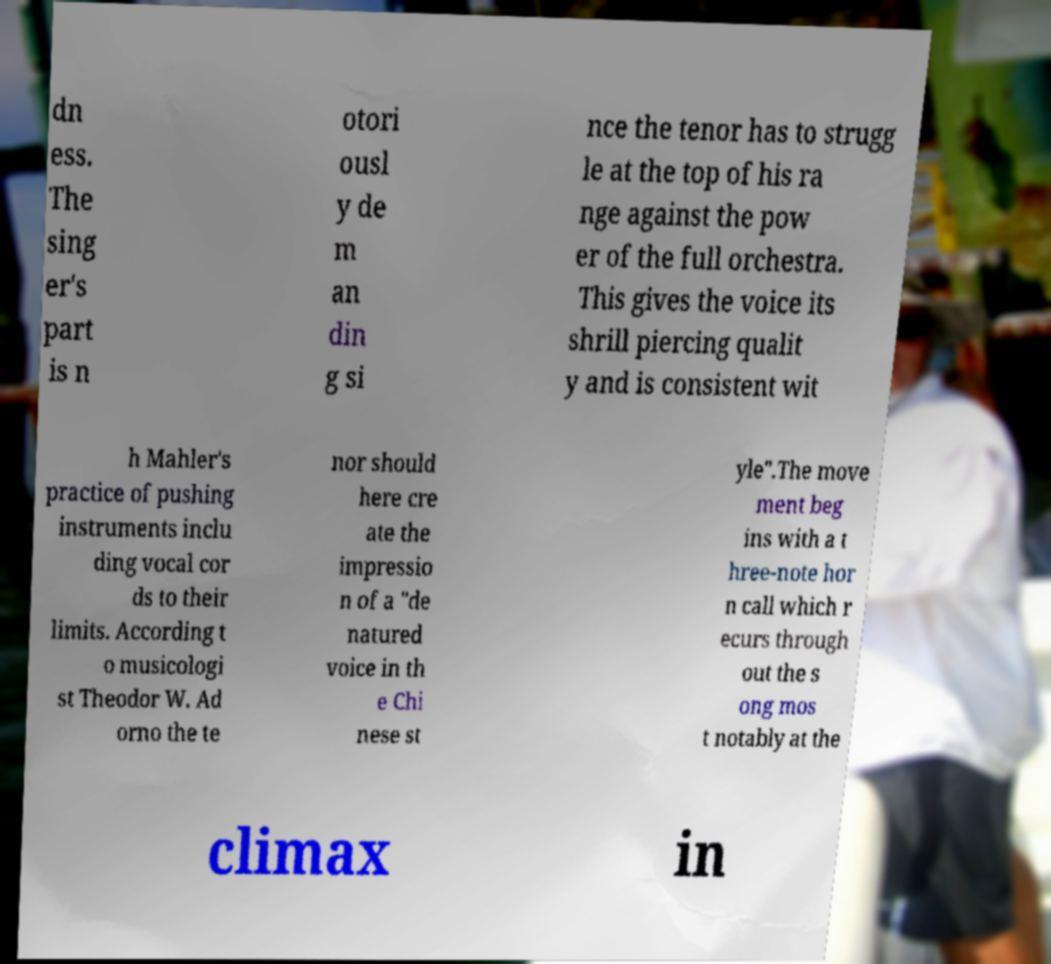There's text embedded in this image that I need extracted. Can you transcribe it verbatim? dn ess. The sing er's part is n otori ousl y de m an din g si nce the tenor has to strugg le at the top of his ra nge against the pow er of the full orchestra. This gives the voice its shrill piercing qualit y and is consistent wit h Mahler's practice of pushing instruments inclu ding vocal cor ds to their limits. According t o musicologi st Theodor W. Ad orno the te nor should here cre ate the impressio n of a "de natured voice in th e Chi nese st yle".The move ment beg ins with a t hree-note hor n call which r ecurs through out the s ong mos t notably at the climax in 